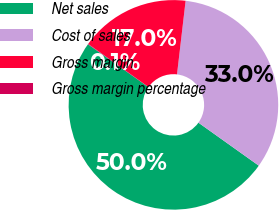Convert chart to OTSL. <chart><loc_0><loc_0><loc_500><loc_500><pie_chart><fcel>Net sales<fcel>Cost of sales<fcel>Gross margin<fcel>Gross margin percentage<nl><fcel>49.96%<fcel>32.99%<fcel>16.97%<fcel>0.07%<nl></chart> 